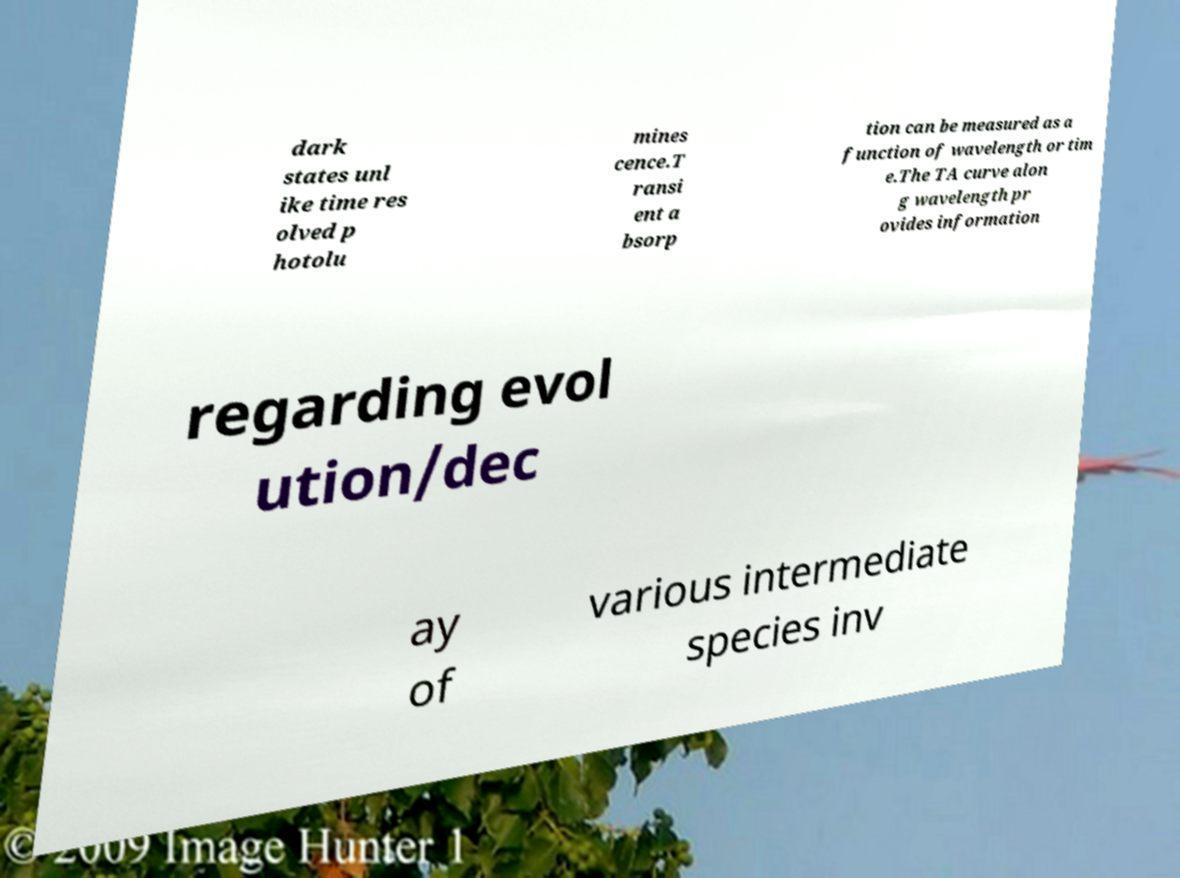There's text embedded in this image that I need extracted. Can you transcribe it verbatim? dark states unl ike time res olved p hotolu mines cence.T ransi ent a bsorp tion can be measured as a function of wavelength or tim e.The TA curve alon g wavelength pr ovides information regarding evol ution/dec ay of various intermediate species inv 